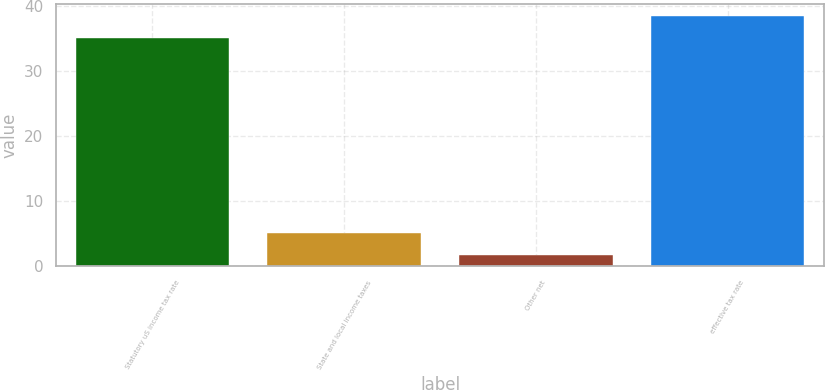<chart> <loc_0><loc_0><loc_500><loc_500><bar_chart><fcel>Statutory uS income tax rate<fcel>State and local income taxes<fcel>Other net<fcel>effective tax rate<nl><fcel>35<fcel>5.15<fcel>1.8<fcel>38.35<nl></chart> 